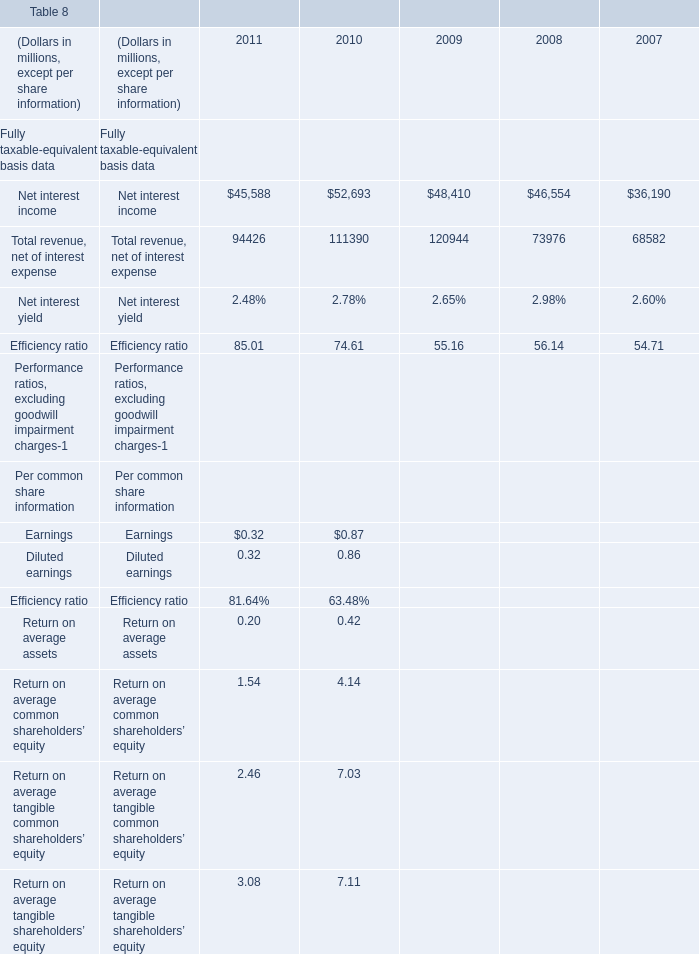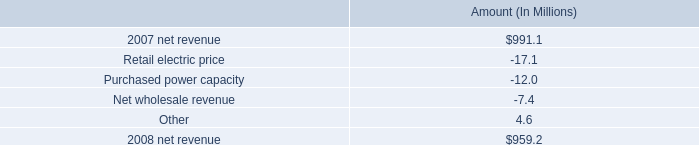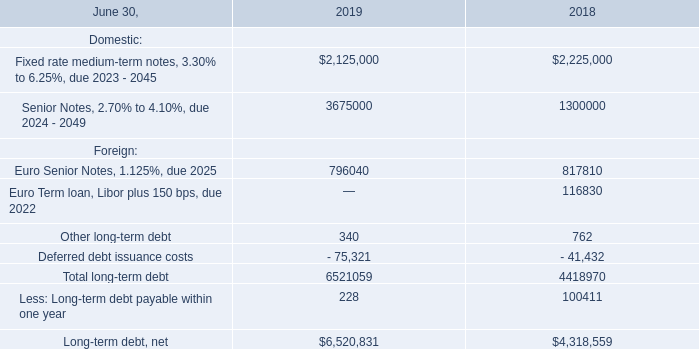What is the growing rate of Net interest income in table 0 in the year with the most Total revenue, net of interest expense in table 0? 
Computations: ((48410 - 46554) / 46554)
Answer: 0.03987. What's the average of Net interest income in 2010 and 2011? (in millions) 
Computations: ((45588 + 52693) / 2)
Answer: 49140.5. Which year is Total revenue, net of interest expense the most? 
Answer: 2009. 